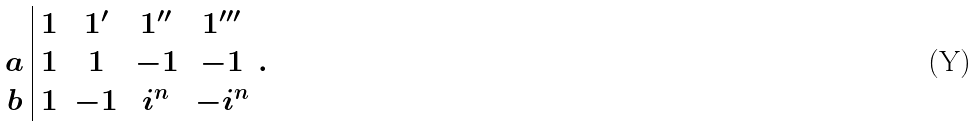<formula> <loc_0><loc_0><loc_500><loc_500>\begin{array} { c | c c c c } & 1 & 1 ^ { \prime } & 1 ^ { \prime \prime } & 1 ^ { \prime \prime \prime } \\ a & 1 & 1 & - 1 & - 1 \\ b & 1 & - 1 & i ^ { n } & - i ^ { n } \end{array} .</formula> 